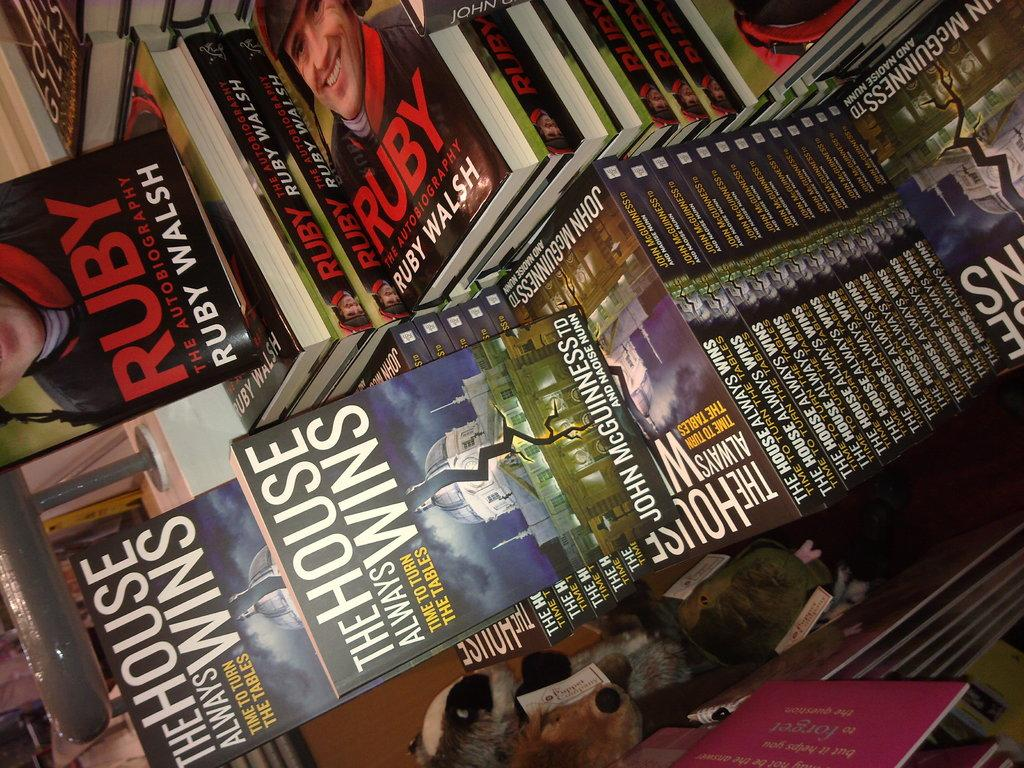Provide a one-sentence caption for the provided image. Books are piled up, including Ruday and The House Always Wins. 